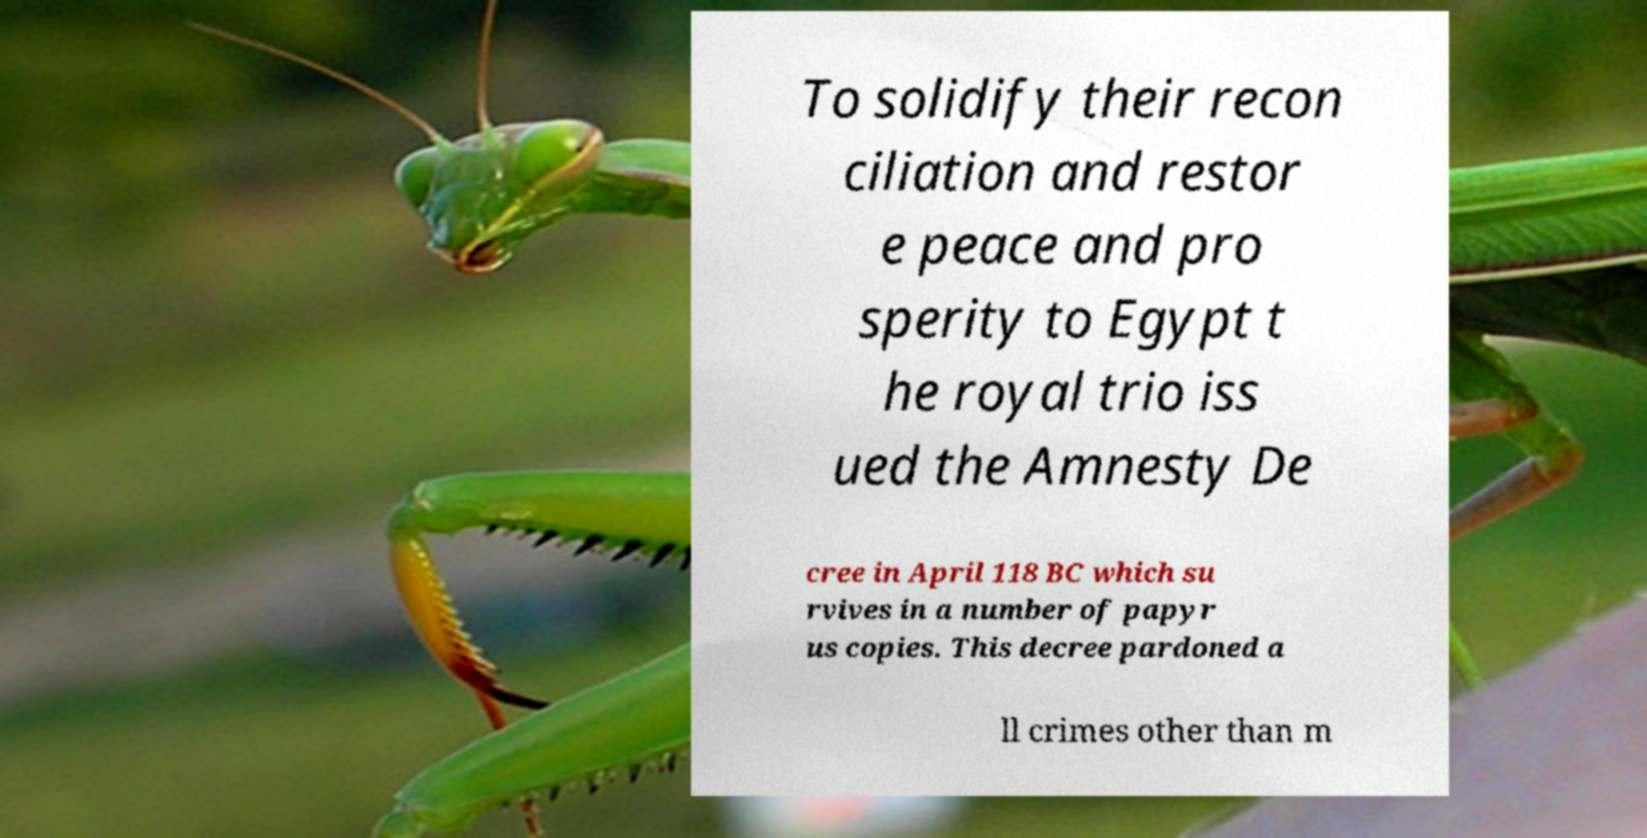Please read and relay the text visible in this image. What does it say? To solidify their recon ciliation and restor e peace and pro sperity to Egypt t he royal trio iss ued the Amnesty De cree in April 118 BC which su rvives in a number of papyr us copies. This decree pardoned a ll crimes other than m 